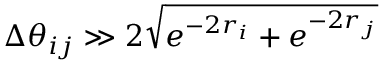Convert formula to latex. <formula><loc_0><loc_0><loc_500><loc_500>\Delta \theta _ { i j } \gg 2 \sqrt { e ^ { - 2 r _ { i } } + e ^ { - 2 r _ { j } } }</formula> 